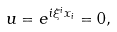Convert formula to latex. <formula><loc_0><loc_0><loc_500><loc_500>u = e ^ { i \xi ^ { i } x _ { i } } = 0 ,</formula> 